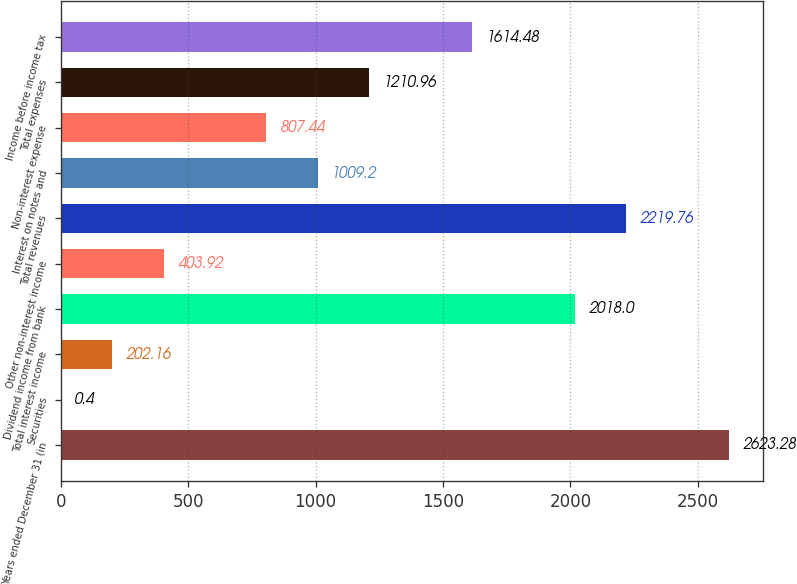Convert chart. <chart><loc_0><loc_0><loc_500><loc_500><bar_chart><fcel>Years ended December 31 (in<fcel>Securities<fcel>Total interest income<fcel>Dividend income from bank<fcel>Other non-interest income<fcel>Total revenues<fcel>Interest on notes and<fcel>Non-interest expense<fcel>Total expenses<fcel>Income before income tax<nl><fcel>2623.28<fcel>0.4<fcel>202.16<fcel>2018<fcel>403.92<fcel>2219.76<fcel>1009.2<fcel>807.44<fcel>1210.96<fcel>1614.48<nl></chart> 